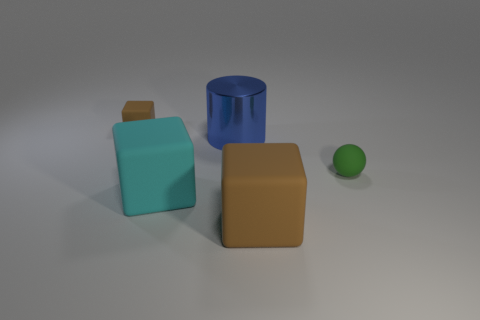Add 4 cyan cubes. How many objects exist? 9 Subtract all purple spheres. How many brown cubes are left? 2 Subtract all brown cubes. How many cubes are left? 1 Subtract all cyan cubes. How many cubes are left? 2 Subtract all blocks. How many objects are left? 2 Add 2 small matte balls. How many small matte balls exist? 3 Subtract 1 blue cylinders. How many objects are left? 4 Subtract all blue blocks. Subtract all purple cylinders. How many blocks are left? 3 Subtract all green spheres. Subtract all big cyan matte blocks. How many objects are left? 3 Add 4 tiny brown objects. How many tiny brown objects are left? 5 